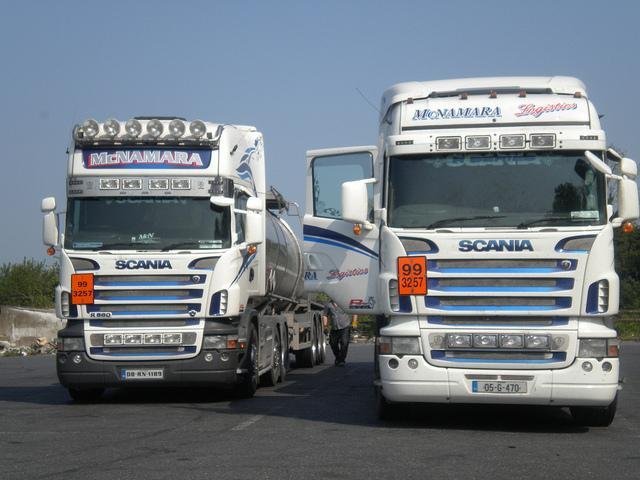What business are these vehicles in? hauling 